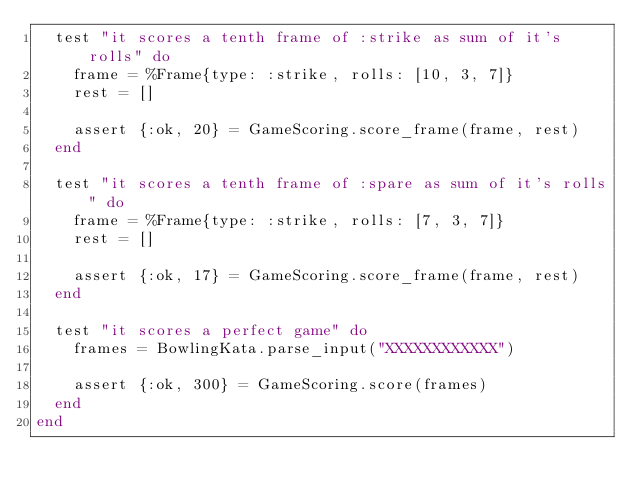Convert code to text. <code><loc_0><loc_0><loc_500><loc_500><_Elixir_>  test "it scores a tenth frame of :strike as sum of it's rolls" do
    frame = %Frame{type: :strike, rolls: [10, 3, 7]}
    rest = []

    assert {:ok, 20} = GameScoring.score_frame(frame, rest)
  end

  test "it scores a tenth frame of :spare as sum of it's rolls" do
    frame = %Frame{type: :strike, rolls: [7, 3, 7]}
    rest = []

    assert {:ok, 17} = GameScoring.score_frame(frame, rest)
  end

  test "it scores a perfect game" do
    frames = BowlingKata.parse_input("XXXXXXXXXXXX")
    
    assert {:ok, 300} = GameScoring.score(frames)
  end
end
</code> 